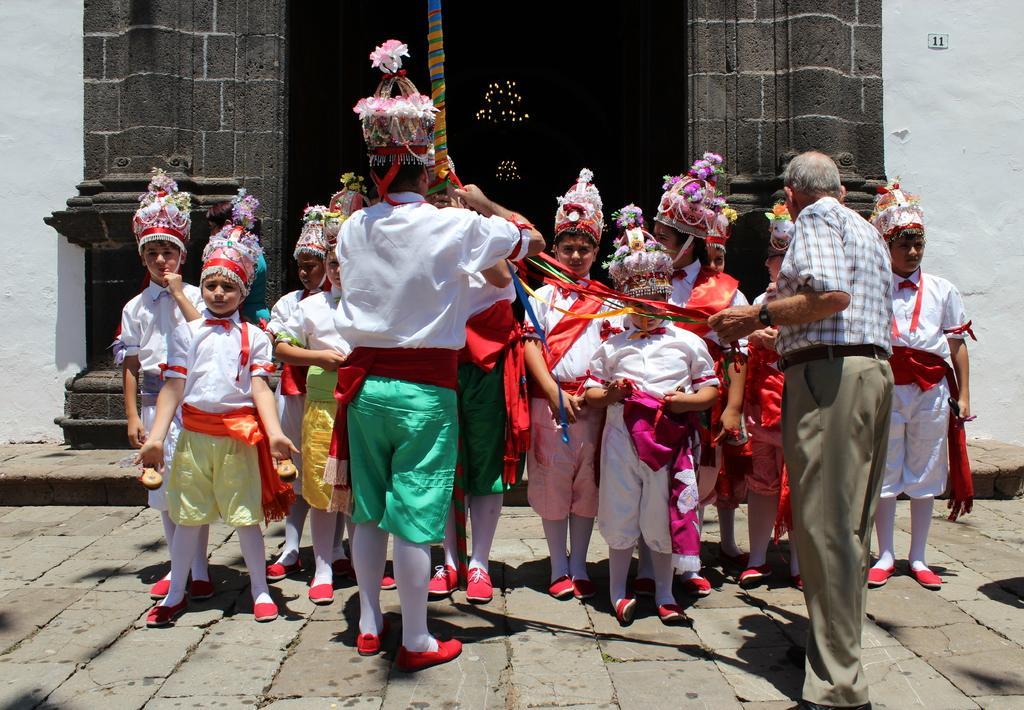Please provide a concise description of this image. On the left side, there is a person in a white color T-shirt, wearing a cap and standing. In front of him, there are children in white colored dresses, standing. On the right side, there is a person in a shirt, standing. In the background, there is a building which is having white wall. Inside the building, there are lights arranged. 